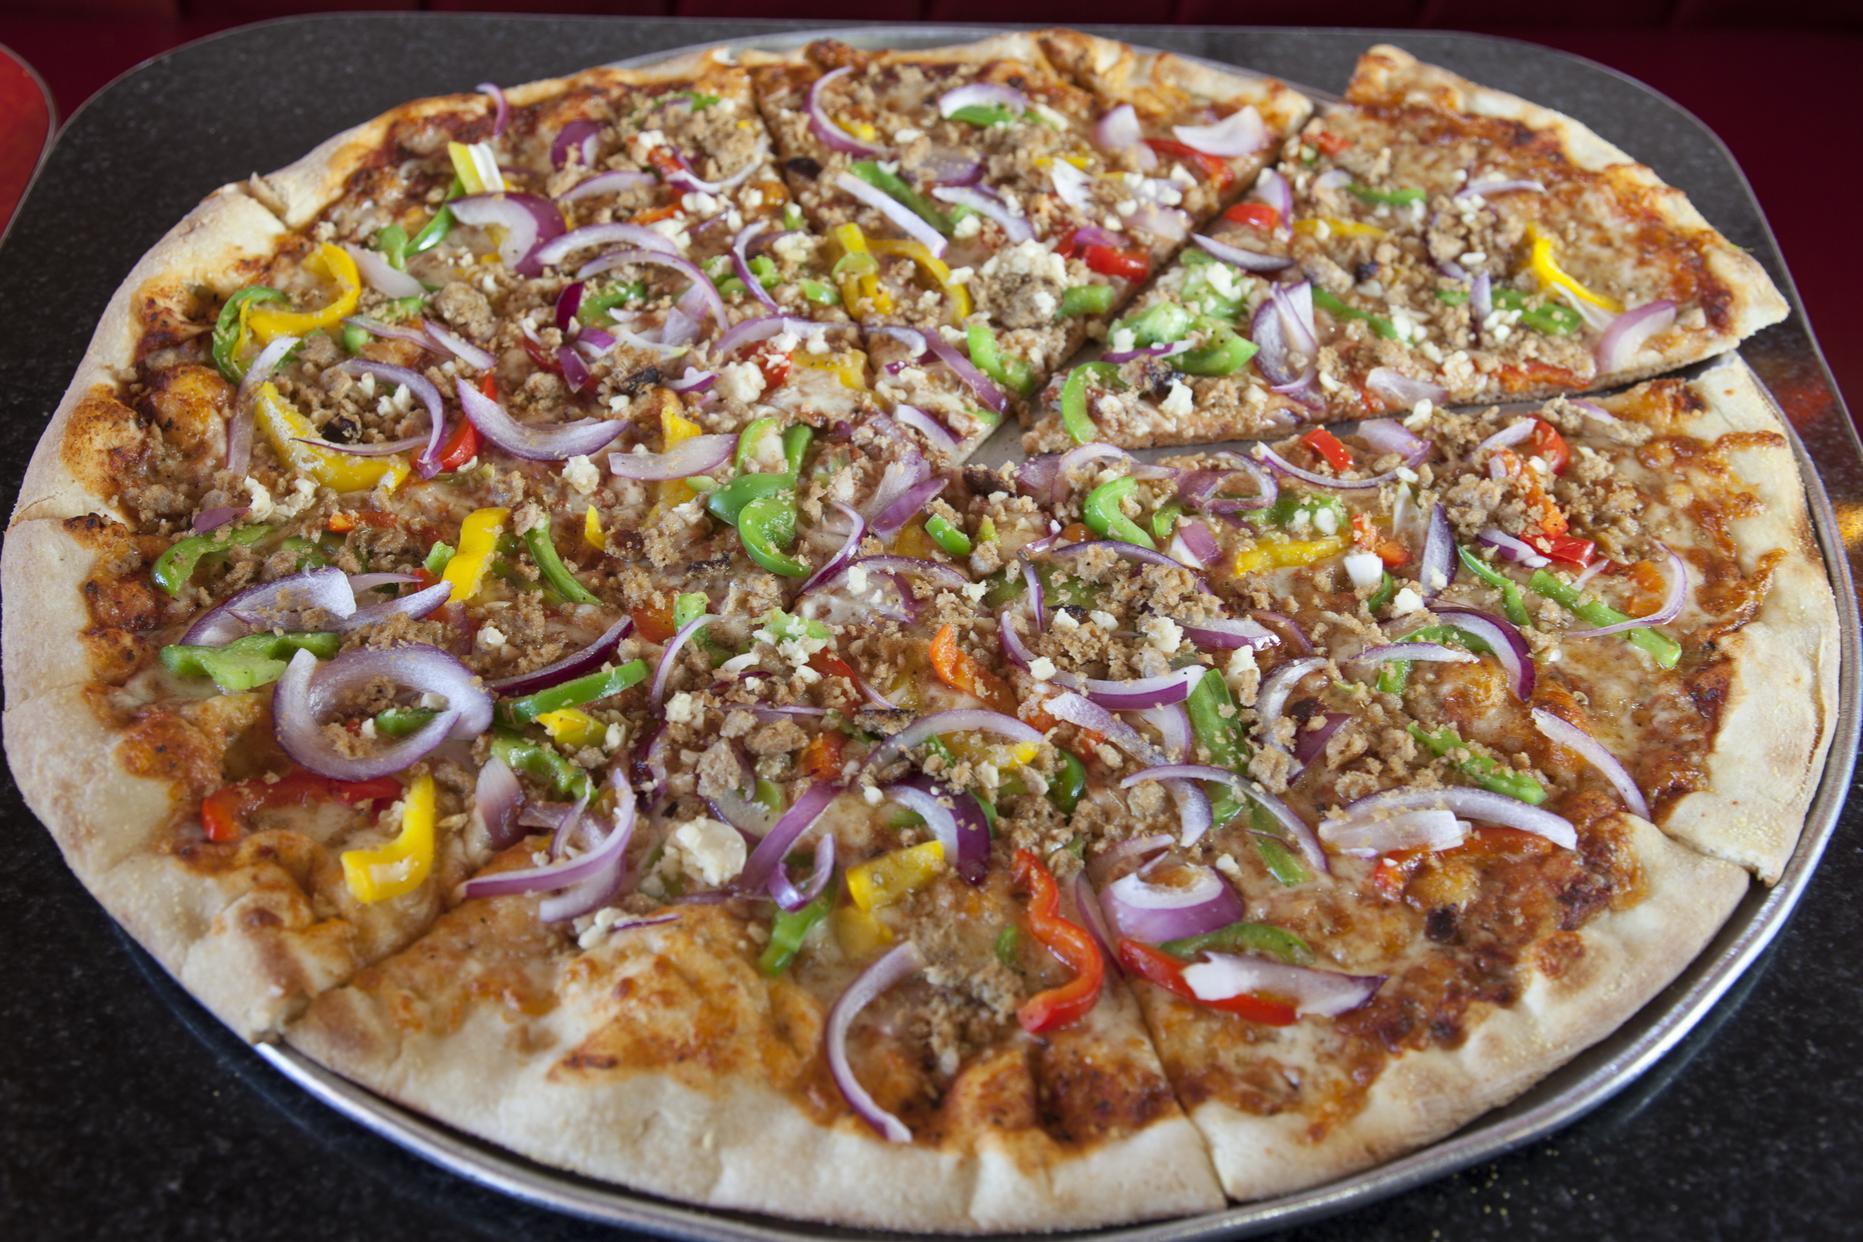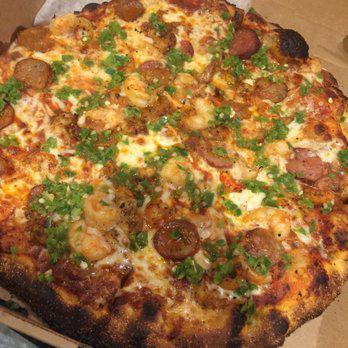The first image is the image on the left, the second image is the image on the right. Assess this claim about the two images: "One image shows an unsliced pizza, and the other image features less than an entire pizza but at least one slice.". Correct or not? Answer yes or no. No. The first image is the image on the left, the second image is the image on the right. For the images displayed, is the sentence "The left and right image contains the same number of full pizzas." factually correct? Answer yes or no. Yes. 